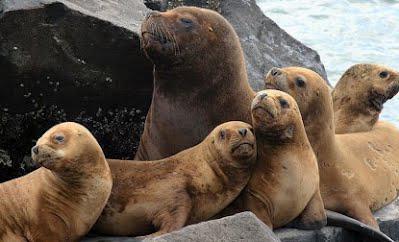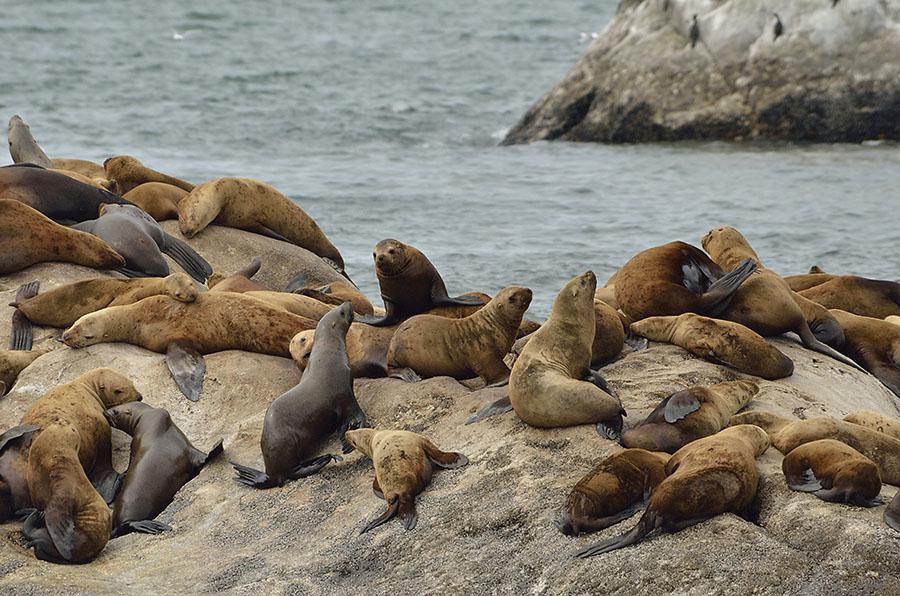The first image is the image on the left, the second image is the image on the right. Given the left and right images, does the statement "An image shows just one seal in the foreground, who is facing left." hold true? Answer yes or no. No. The first image is the image on the left, the second image is the image on the right. Assess this claim about the two images: "the background is hazy in the image on the left". Correct or not? Answer yes or no. No. 